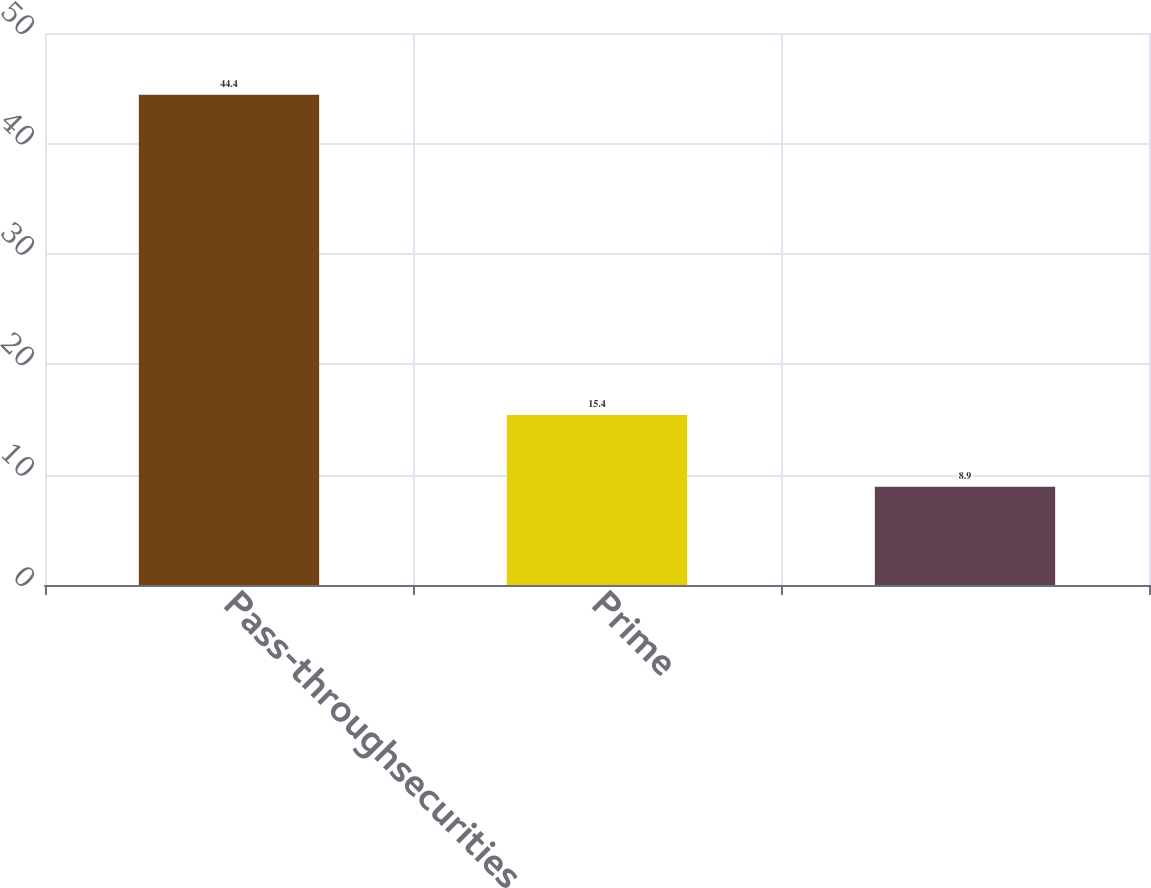Convert chart to OTSL. <chart><loc_0><loc_0><loc_500><loc_500><bar_chart><fcel>Pass-throughsecurities<fcel>Prime<fcel>Unnamed: 2<nl><fcel>44.4<fcel>15.4<fcel>8.9<nl></chart> 